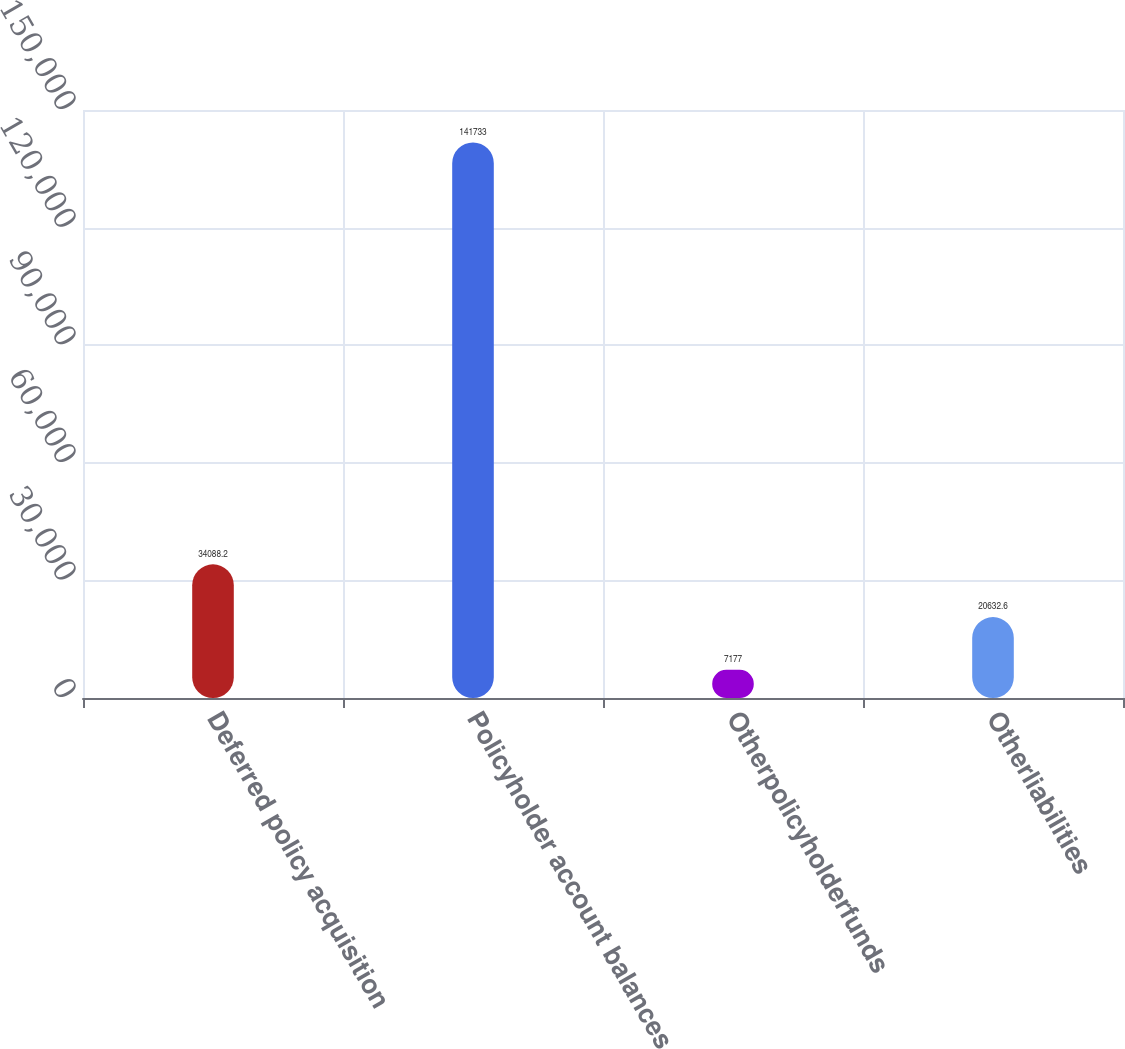Convert chart to OTSL. <chart><loc_0><loc_0><loc_500><loc_500><bar_chart><fcel>Deferred policy acquisition<fcel>Policyholder account balances<fcel>Otherpolicyholderfunds<fcel>Otherliabilities<nl><fcel>34088.2<fcel>141733<fcel>7177<fcel>20632.6<nl></chart> 